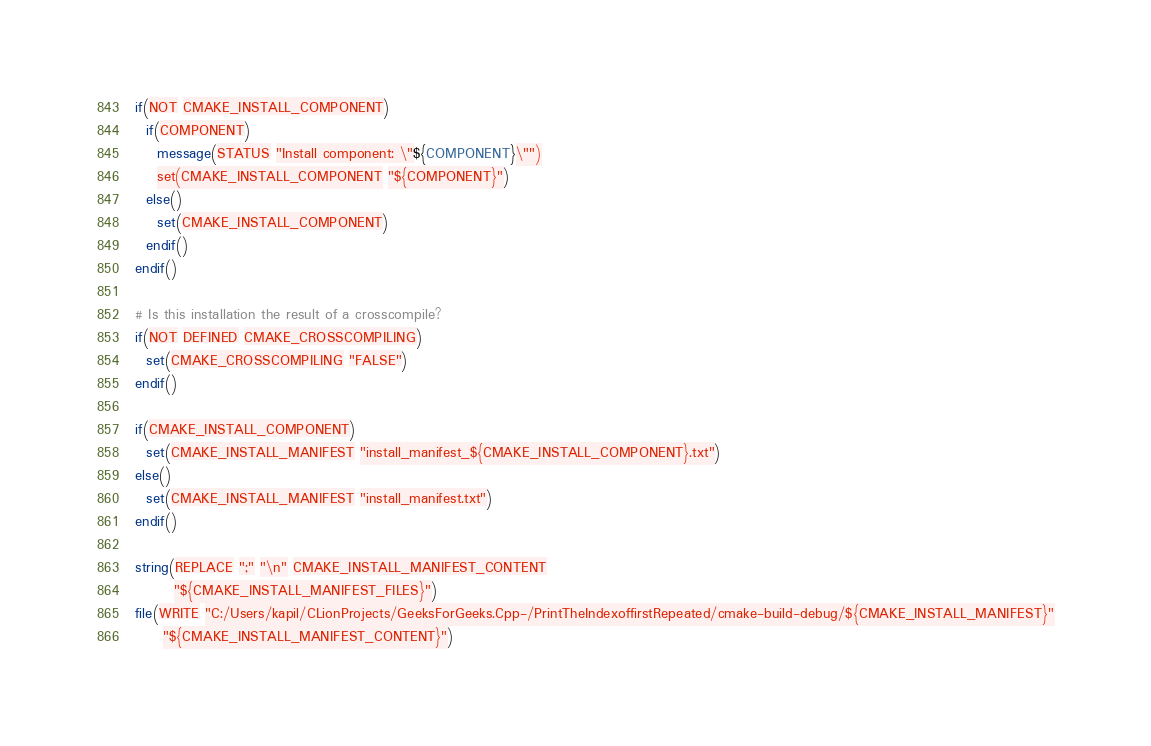Convert code to text. <code><loc_0><loc_0><loc_500><loc_500><_CMake_>if(NOT CMAKE_INSTALL_COMPONENT)
  if(COMPONENT)
    message(STATUS "Install component: \"${COMPONENT}\"")
    set(CMAKE_INSTALL_COMPONENT "${COMPONENT}")
  else()
    set(CMAKE_INSTALL_COMPONENT)
  endif()
endif()

# Is this installation the result of a crosscompile?
if(NOT DEFINED CMAKE_CROSSCOMPILING)
  set(CMAKE_CROSSCOMPILING "FALSE")
endif()

if(CMAKE_INSTALL_COMPONENT)
  set(CMAKE_INSTALL_MANIFEST "install_manifest_${CMAKE_INSTALL_COMPONENT}.txt")
else()
  set(CMAKE_INSTALL_MANIFEST "install_manifest.txt")
endif()

string(REPLACE ";" "\n" CMAKE_INSTALL_MANIFEST_CONTENT
       "${CMAKE_INSTALL_MANIFEST_FILES}")
file(WRITE "C:/Users/kapil/CLionProjects/GeeksForGeeks.Cpp-/PrintTheIndexoffirstRepeated/cmake-build-debug/${CMAKE_INSTALL_MANIFEST}"
     "${CMAKE_INSTALL_MANIFEST_CONTENT}")
</code> 